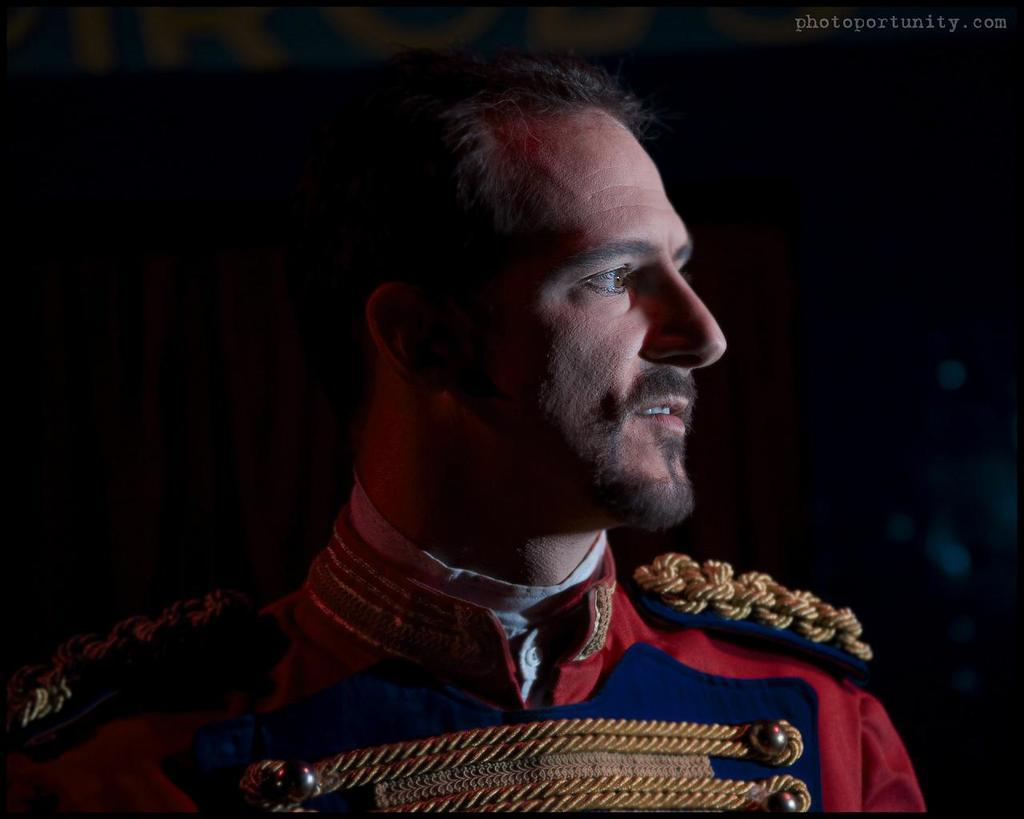What is the main subject of the image? There is a person in the center of the image. Can you describe the person's attire? The person is wearing a red color dress. Is there any text visible in the image? Yes, there is some text printed in the top corner of the image. How does the sponge expand in the image? There is no sponge present in the image, so it cannot expand. 